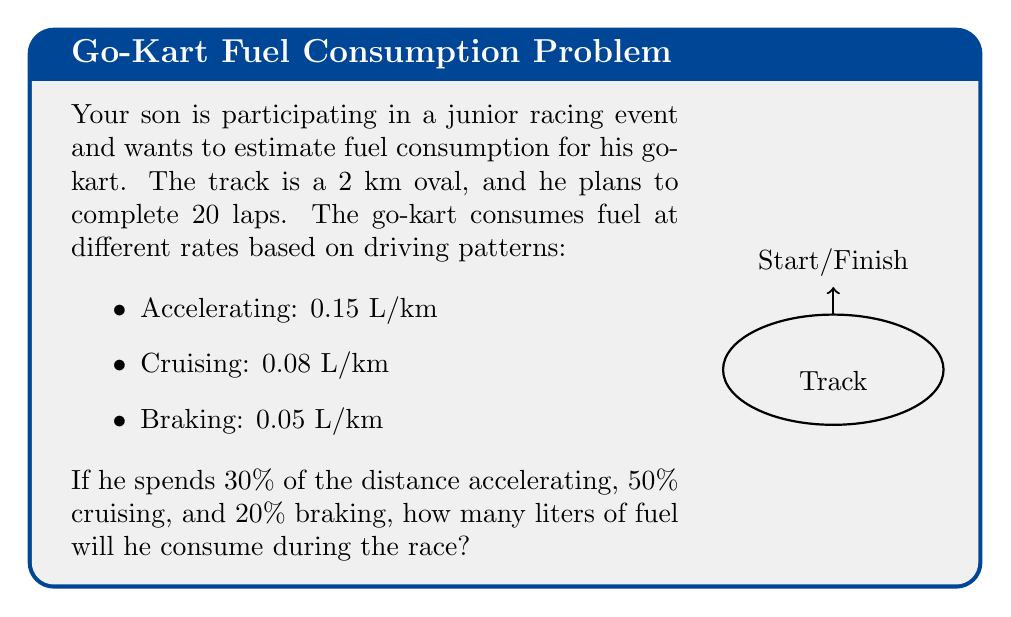Show me your answer to this math problem. Let's break this down step-by-step:

1) First, calculate the total distance:
   $$ \text{Total distance} = 20 \text{ laps} \times 2 \text{ km/lap} = 40 \text{ km} $$

2) Now, determine the distance for each driving pattern:
   - Accelerating: $40 \text{ km} \times 30\% = 12 \text{ km}$
   - Cruising: $40 \text{ km} \times 50\% = 20 \text{ km}$
   - Braking: $40 \text{ km} \times 20\% = 8 \text{ km}$

3) Calculate fuel consumption for each pattern:
   - Accelerating: $12 \text{ km} \times 0.15 \text{ L/km} = 1.8 \text{ L}$
   - Cruising: $20 \text{ km} \times 0.08 \text{ L/km} = 1.6 \text{ L}$
   - Braking: $8 \text{ km} \times 0.05 \text{ L/km} = 0.4 \text{ L}$

4) Sum up the total fuel consumption:
   $$ \text{Total fuel} = 1.8 \text{ L} + 1.6 \text{ L} + 0.4 \text{ L} = 3.8 \text{ L} $$
Answer: 3.8 L 